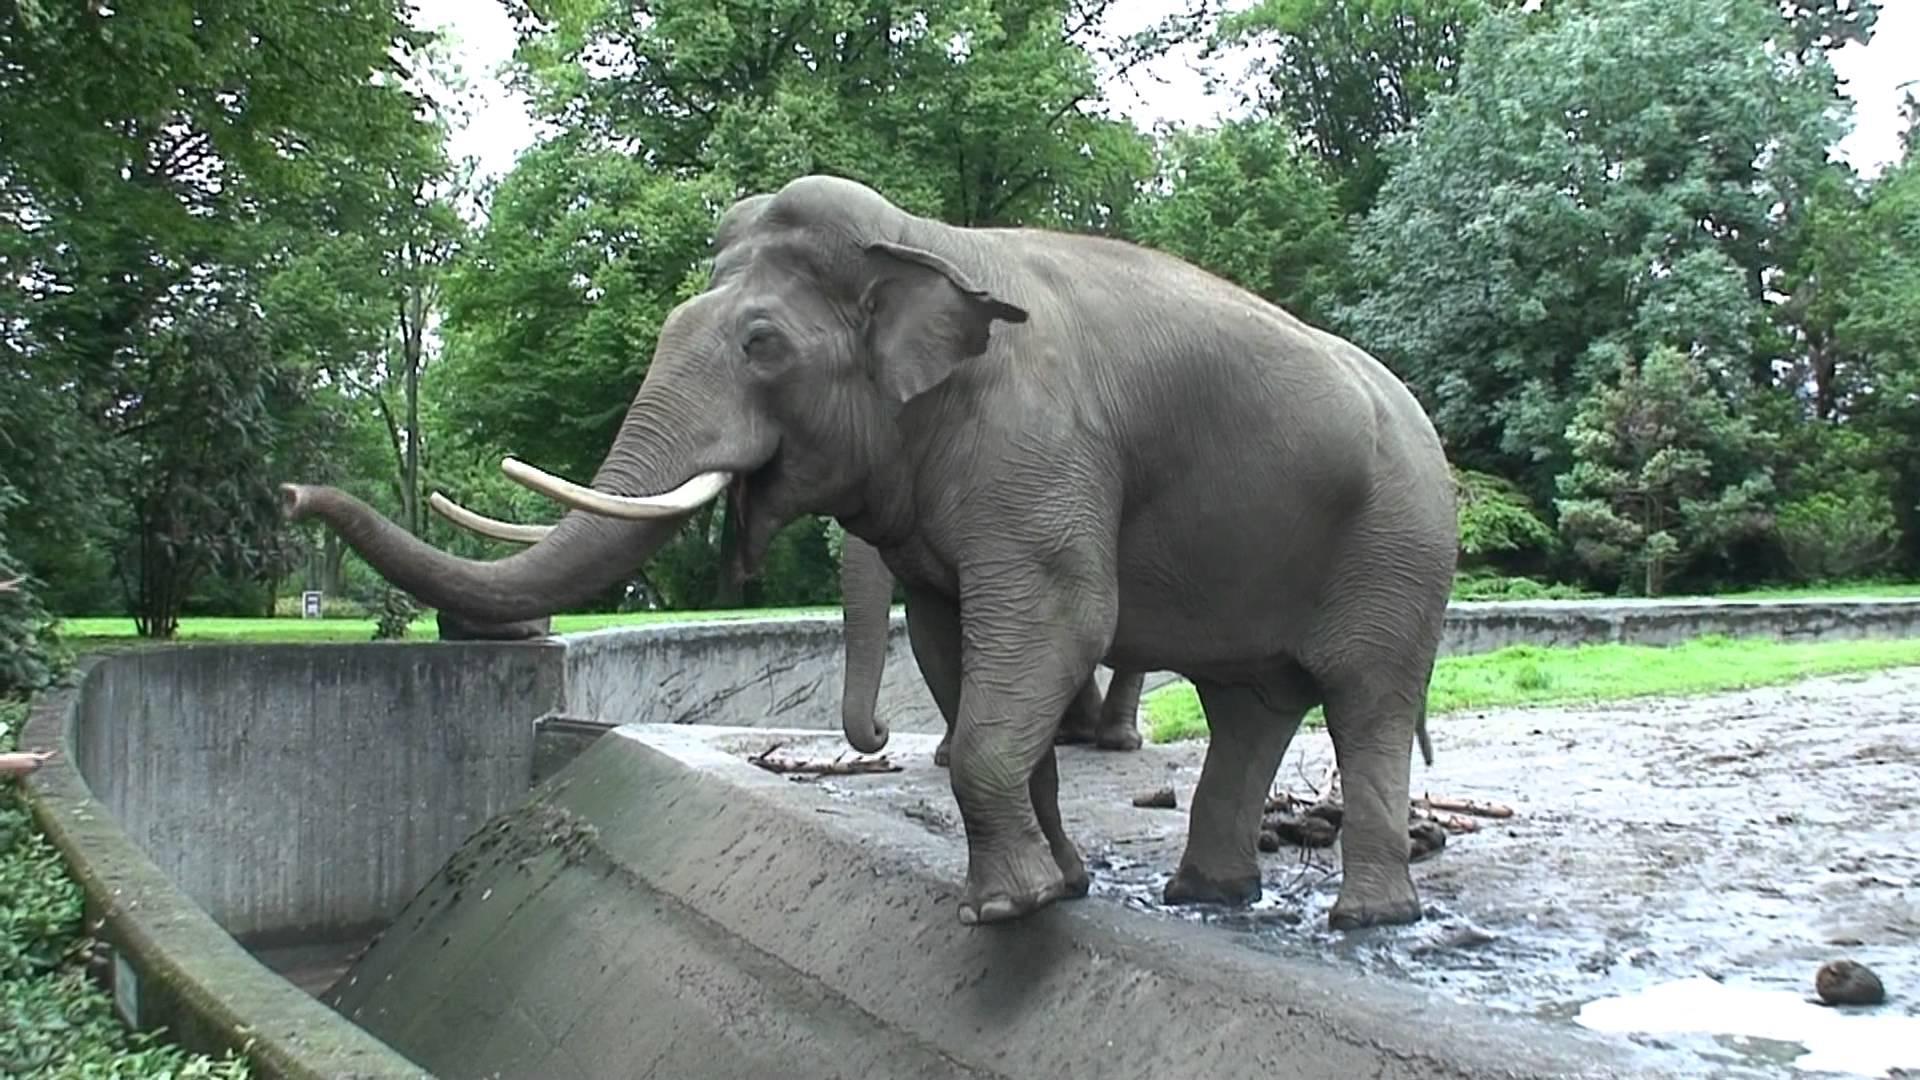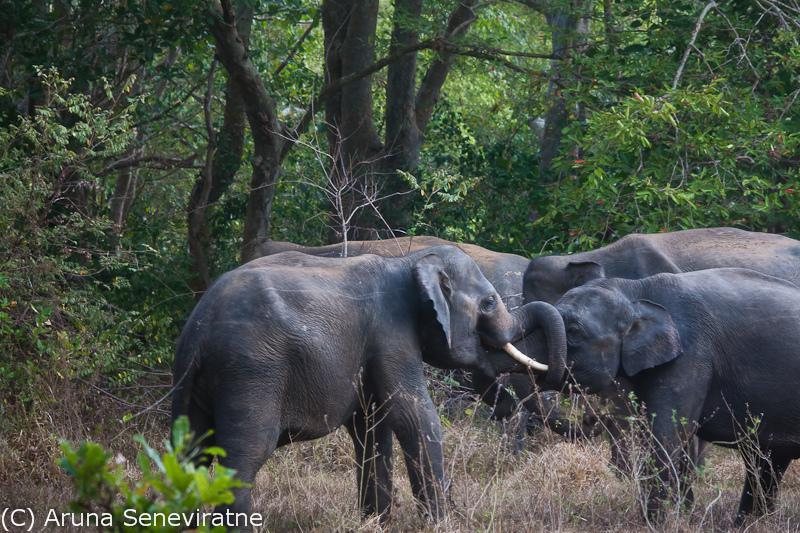The first image is the image on the left, the second image is the image on the right. Analyze the images presented: Is the assertion "One image shows at least one elephant standing in a wet area." valid? Answer yes or no. Yes. 